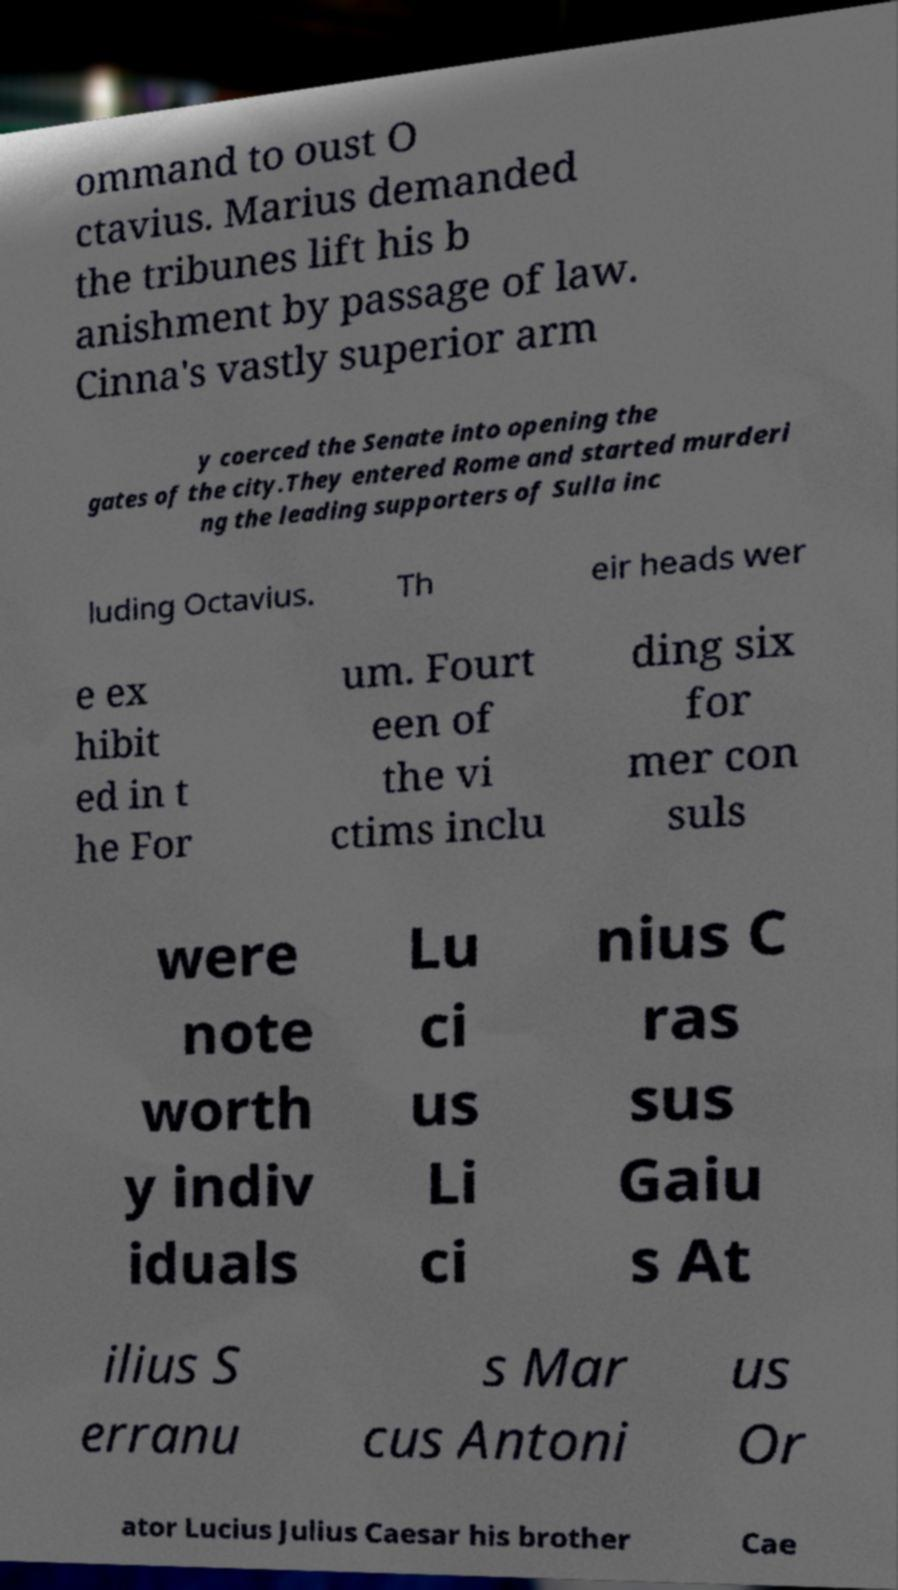Could you extract and type out the text from this image? ommand to oust O ctavius. Marius demanded the tribunes lift his b anishment by passage of law. Cinna's vastly superior arm y coerced the Senate into opening the gates of the city.They entered Rome and started murderi ng the leading supporters of Sulla inc luding Octavius. Th eir heads wer e ex hibit ed in t he For um. Fourt een of the vi ctims inclu ding six for mer con suls were note worth y indiv iduals Lu ci us Li ci nius C ras sus Gaiu s At ilius S erranu s Mar cus Antoni us Or ator Lucius Julius Caesar his brother Cae 